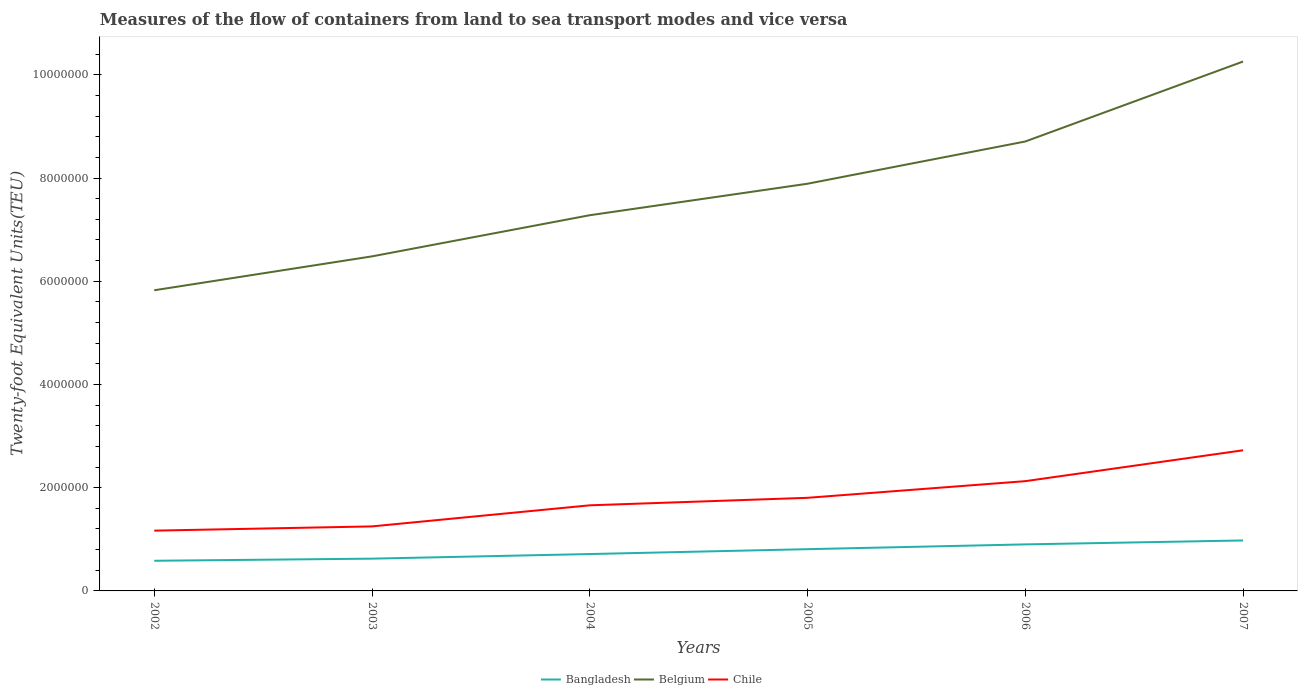Does the line corresponding to Chile intersect with the line corresponding to Belgium?
Provide a succinct answer. No. Across all years, what is the maximum container port traffic in Bangladesh?
Make the answer very short. 5.84e+05. In which year was the container port traffic in Belgium maximum?
Give a very brief answer. 2002. What is the total container port traffic in Belgium in the graph?
Give a very brief answer. -2.98e+06. What is the difference between the highest and the second highest container port traffic in Bangladesh?
Offer a terse response. 3.94e+05. What is the difference between the highest and the lowest container port traffic in Chile?
Your response must be concise. 3. Is the container port traffic in Bangladesh strictly greater than the container port traffic in Chile over the years?
Give a very brief answer. Yes. How many years are there in the graph?
Offer a very short reply. 6. What is the difference between two consecutive major ticks on the Y-axis?
Your response must be concise. 2.00e+06. Are the values on the major ticks of Y-axis written in scientific E-notation?
Your answer should be very brief. No. Where does the legend appear in the graph?
Your answer should be compact. Bottom center. How are the legend labels stacked?
Your response must be concise. Horizontal. What is the title of the graph?
Your answer should be compact. Measures of the flow of containers from land to sea transport modes and vice versa. What is the label or title of the Y-axis?
Provide a succinct answer. Twenty-foot Equivalent Units(TEU). What is the Twenty-foot Equivalent Units(TEU) of Bangladesh in 2002?
Provide a succinct answer. 5.84e+05. What is the Twenty-foot Equivalent Units(TEU) in Belgium in 2002?
Your answer should be very brief. 5.83e+06. What is the Twenty-foot Equivalent Units(TEU) of Chile in 2002?
Make the answer very short. 1.17e+06. What is the Twenty-foot Equivalent Units(TEU) in Bangladesh in 2003?
Your answer should be very brief. 6.25e+05. What is the Twenty-foot Equivalent Units(TEU) of Belgium in 2003?
Offer a terse response. 6.48e+06. What is the Twenty-foot Equivalent Units(TEU) of Chile in 2003?
Your response must be concise. 1.25e+06. What is the Twenty-foot Equivalent Units(TEU) of Bangladesh in 2004?
Provide a succinct answer. 7.14e+05. What is the Twenty-foot Equivalent Units(TEU) of Belgium in 2004?
Provide a short and direct response. 7.28e+06. What is the Twenty-foot Equivalent Units(TEU) of Chile in 2004?
Provide a succinct answer. 1.66e+06. What is the Twenty-foot Equivalent Units(TEU) of Bangladesh in 2005?
Offer a very short reply. 8.09e+05. What is the Twenty-foot Equivalent Units(TEU) of Belgium in 2005?
Your answer should be compact. 7.89e+06. What is the Twenty-foot Equivalent Units(TEU) in Chile in 2005?
Your response must be concise. 1.80e+06. What is the Twenty-foot Equivalent Units(TEU) of Bangladesh in 2006?
Keep it short and to the point. 9.02e+05. What is the Twenty-foot Equivalent Units(TEU) of Belgium in 2006?
Offer a very short reply. 8.71e+06. What is the Twenty-foot Equivalent Units(TEU) in Chile in 2006?
Your answer should be very brief. 2.13e+06. What is the Twenty-foot Equivalent Units(TEU) of Bangladesh in 2007?
Make the answer very short. 9.78e+05. What is the Twenty-foot Equivalent Units(TEU) of Belgium in 2007?
Keep it short and to the point. 1.03e+07. What is the Twenty-foot Equivalent Units(TEU) of Chile in 2007?
Provide a short and direct response. 2.73e+06. Across all years, what is the maximum Twenty-foot Equivalent Units(TEU) in Bangladesh?
Ensure brevity in your answer.  9.78e+05. Across all years, what is the maximum Twenty-foot Equivalent Units(TEU) of Belgium?
Offer a terse response. 1.03e+07. Across all years, what is the maximum Twenty-foot Equivalent Units(TEU) of Chile?
Offer a very short reply. 2.73e+06. Across all years, what is the minimum Twenty-foot Equivalent Units(TEU) in Bangladesh?
Offer a terse response. 5.84e+05. Across all years, what is the minimum Twenty-foot Equivalent Units(TEU) of Belgium?
Your answer should be compact. 5.83e+06. Across all years, what is the minimum Twenty-foot Equivalent Units(TEU) of Chile?
Keep it short and to the point. 1.17e+06. What is the total Twenty-foot Equivalent Units(TEU) of Bangladesh in the graph?
Make the answer very short. 4.61e+06. What is the total Twenty-foot Equivalent Units(TEU) in Belgium in the graph?
Keep it short and to the point. 4.64e+07. What is the total Twenty-foot Equivalent Units(TEU) of Chile in the graph?
Your answer should be very brief. 1.07e+07. What is the difference between the Twenty-foot Equivalent Units(TEU) in Bangladesh in 2002 and that in 2003?
Give a very brief answer. -4.09e+04. What is the difference between the Twenty-foot Equivalent Units(TEU) of Belgium in 2002 and that in 2003?
Your response must be concise. -6.57e+05. What is the difference between the Twenty-foot Equivalent Units(TEU) in Chile in 2002 and that in 2003?
Make the answer very short. -8.22e+04. What is the difference between the Twenty-foot Equivalent Units(TEU) of Bangladesh in 2002 and that in 2004?
Your answer should be compact. -1.30e+05. What is the difference between the Twenty-foot Equivalent Units(TEU) of Belgium in 2002 and that in 2004?
Provide a succinct answer. -1.45e+06. What is the difference between the Twenty-foot Equivalent Units(TEU) in Chile in 2002 and that in 2004?
Make the answer very short. -4.91e+05. What is the difference between the Twenty-foot Equivalent Units(TEU) in Bangladesh in 2002 and that in 2005?
Ensure brevity in your answer.  -2.25e+05. What is the difference between the Twenty-foot Equivalent Units(TEU) of Belgium in 2002 and that in 2005?
Ensure brevity in your answer.  -2.06e+06. What is the difference between the Twenty-foot Equivalent Units(TEU) in Chile in 2002 and that in 2005?
Give a very brief answer. -6.36e+05. What is the difference between the Twenty-foot Equivalent Units(TEU) of Bangladesh in 2002 and that in 2006?
Keep it short and to the point. -3.17e+05. What is the difference between the Twenty-foot Equivalent Units(TEU) of Belgium in 2002 and that in 2006?
Offer a very short reply. -2.88e+06. What is the difference between the Twenty-foot Equivalent Units(TEU) in Chile in 2002 and that in 2006?
Offer a very short reply. -9.59e+05. What is the difference between the Twenty-foot Equivalent Units(TEU) in Bangladesh in 2002 and that in 2007?
Make the answer very short. -3.94e+05. What is the difference between the Twenty-foot Equivalent Units(TEU) in Belgium in 2002 and that in 2007?
Ensure brevity in your answer.  -4.43e+06. What is the difference between the Twenty-foot Equivalent Units(TEU) of Chile in 2002 and that in 2007?
Provide a succinct answer. -1.56e+06. What is the difference between the Twenty-foot Equivalent Units(TEU) of Bangladesh in 2003 and that in 2004?
Keep it short and to the point. -8.93e+04. What is the difference between the Twenty-foot Equivalent Units(TEU) of Belgium in 2003 and that in 2004?
Provide a succinct answer. -7.97e+05. What is the difference between the Twenty-foot Equivalent Units(TEU) of Chile in 2003 and that in 2004?
Offer a terse response. -4.09e+05. What is the difference between the Twenty-foot Equivalent Units(TEU) of Bangladesh in 2003 and that in 2005?
Offer a terse response. -1.84e+05. What is the difference between the Twenty-foot Equivalent Units(TEU) in Belgium in 2003 and that in 2005?
Provide a succinct answer. -1.41e+06. What is the difference between the Twenty-foot Equivalent Units(TEU) in Chile in 2003 and that in 2005?
Provide a short and direct response. -5.54e+05. What is the difference between the Twenty-foot Equivalent Units(TEU) in Bangladesh in 2003 and that in 2006?
Your answer should be very brief. -2.76e+05. What is the difference between the Twenty-foot Equivalent Units(TEU) in Belgium in 2003 and that in 2006?
Offer a terse response. -2.23e+06. What is the difference between the Twenty-foot Equivalent Units(TEU) in Chile in 2003 and that in 2006?
Ensure brevity in your answer.  -8.77e+05. What is the difference between the Twenty-foot Equivalent Units(TEU) of Bangladesh in 2003 and that in 2007?
Your answer should be compact. -3.53e+05. What is the difference between the Twenty-foot Equivalent Units(TEU) in Belgium in 2003 and that in 2007?
Offer a very short reply. -3.78e+06. What is the difference between the Twenty-foot Equivalent Units(TEU) in Chile in 2003 and that in 2007?
Provide a succinct answer. -1.48e+06. What is the difference between the Twenty-foot Equivalent Units(TEU) in Bangladesh in 2004 and that in 2005?
Provide a succinct answer. -9.45e+04. What is the difference between the Twenty-foot Equivalent Units(TEU) in Belgium in 2004 and that in 2005?
Your answer should be very brief. -6.10e+05. What is the difference between the Twenty-foot Equivalent Units(TEU) in Chile in 2004 and that in 2005?
Your answer should be very brief. -1.46e+05. What is the difference between the Twenty-foot Equivalent Units(TEU) of Bangladesh in 2004 and that in 2006?
Ensure brevity in your answer.  -1.87e+05. What is the difference between the Twenty-foot Equivalent Units(TEU) of Belgium in 2004 and that in 2006?
Your answer should be very brief. -1.43e+06. What is the difference between the Twenty-foot Equivalent Units(TEU) of Chile in 2004 and that in 2006?
Ensure brevity in your answer.  -4.68e+05. What is the difference between the Twenty-foot Equivalent Units(TEU) in Bangladesh in 2004 and that in 2007?
Make the answer very short. -2.64e+05. What is the difference between the Twenty-foot Equivalent Units(TEU) in Belgium in 2004 and that in 2007?
Your answer should be compact. -2.98e+06. What is the difference between the Twenty-foot Equivalent Units(TEU) in Chile in 2004 and that in 2007?
Make the answer very short. -1.07e+06. What is the difference between the Twenty-foot Equivalent Units(TEU) in Bangladesh in 2005 and that in 2006?
Your answer should be compact. -9.26e+04. What is the difference between the Twenty-foot Equivalent Units(TEU) in Belgium in 2005 and that in 2006?
Provide a short and direct response. -8.18e+05. What is the difference between the Twenty-foot Equivalent Units(TEU) of Chile in 2005 and that in 2006?
Ensure brevity in your answer.  -3.23e+05. What is the difference between the Twenty-foot Equivalent Units(TEU) in Bangladesh in 2005 and that in 2007?
Keep it short and to the point. -1.69e+05. What is the difference between the Twenty-foot Equivalent Units(TEU) in Belgium in 2005 and that in 2007?
Your response must be concise. -2.37e+06. What is the difference between the Twenty-foot Equivalent Units(TEU) of Chile in 2005 and that in 2007?
Offer a terse response. -9.21e+05. What is the difference between the Twenty-foot Equivalent Units(TEU) of Bangladesh in 2006 and that in 2007?
Give a very brief answer. -7.65e+04. What is the difference between the Twenty-foot Equivalent Units(TEU) in Belgium in 2006 and that in 2007?
Your answer should be very brief. -1.55e+06. What is the difference between the Twenty-foot Equivalent Units(TEU) in Chile in 2006 and that in 2007?
Keep it short and to the point. -5.98e+05. What is the difference between the Twenty-foot Equivalent Units(TEU) of Bangladesh in 2002 and the Twenty-foot Equivalent Units(TEU) of Belgium in 2003?
Make the answer very short. -5.90e+06. What is the difference between the Twenty-foot Equivalent Units(TEU) of Bangladesh in 2002 and the Twenty-foot Equivalent Units(TEU) of Chile in 2003?
Make the answer very short. -6.66e+05. What is the difference between the Twenty-foot Equivalent Units(TEU) in Belgium in 2002 and the Twenty-foot Equivalent Units(TEU) in Chile in 2003?
Ensure brevity in your answer.  4.58e+06. What is the difference between the Twenty-foot Equivalent Units(TEU) of Bangladesh in 2002 and the Twenty-foot Equivalent Units(TEU) of Belgium in 2004?
Provide a succinct answer. -6.70e+06. What is the difference between the Twenty-foot Equivalent Units(TEU) in Bangladesh in 2002 and the Twenty-foot Equivalent Units(TEU) in Chile in 2004?
Offer a terse response. -1.07e+06. What is the difference between the Twenty-foot Equivalent Units(TEU) in Belgium in 2002 and the Twenty-foot Equivalent Units(TEU) in Chile in 2004?
Your response must be concise. 4.17e+06. What is the difference between the Twenty-foot Equivalent Units(TEU) of Bangladesh in 2002 and the Twenty-foot Equivalent Units(TEU) of Belgium in 2005?
Your response must be concise. -7.31e+06. What is the difference between the Twenty-foot Equivalent Units(TEU) of Bangladesh in 2002 and the Twenty-foot Equivalent Units(TEU) of Chile in 2005?
Your answer should be very brief. -1.22e+06. What is the difference between the Twenty-foot Equivalent Units(TEU) in Belgium in 2002 and the Twenty-foot Equivalent Units(TEU) in Chile in 2005?
Provide a succinct answer. 4.02e+06. What is the difference between the Twenty-foot Equivalent Units(TEU) of Bangladesh in 2002 and the Twenty-foot Equivalent Units(TEU) of Belgium in 2006?
Give a very brief answer. -8.12e+06. What is the difference between the Twenty-foot Equivalent Units(TEU) of Bangladesh in 2002 and the Twenty-foot Equivalent Units(TEU) of Chile in 2006?
Make the answer very short. -1.54e+06. What is the difference between the Twenty-foot Equivalent Units(TEU) in Belgium in 2002 and the Twenty-foot Equivalent Units(TEU) in Chile in 2006?
Your response must be concise. 3.70e+06. What is the difference between the Twenty-foot Equivalent Units(TEU) in Bangladesh in 2002 and the Twenty-foot Equivalent Units(TEU) in Belgium in 2007?
Your answer should be very brief. -9.67e+06. What is the difference between the Twenty-foot Equivalent Units(TEU) of Bangladesh in 2002 and the Twenty-foot Equivalent Units(TEU) of Chile in 2007?
Your answer should be compact. -2.14e+06. What is the difference between the Twenty-foot Equivalent Units(TEU) of Belgium in 2002 and the Twenty-foot Equivalent Units(TEU) of Chile in 2007?
Give a very brief answer. 3.10e+06. What is the difference between the Twenty-foot Equivalent Units(TEU) of Bangladesh in 2003 and the Twenty-foot Equivalent Units(TEU) of Belgium in 2004?
Ensure brevity in your answer.  -6.65e+06. What is the difference between the Twenty-foot Equivalent Units(TEU) in Bangladesh in 2003 and the Twenty-foot Equivalent Units(TEU) in Chile in 2004?
Your answer should be very brief. -1.03e+06. What is the difference between the Twenty-foot Equivalent Units(TEU) in Belgium in 2003 and the Twenty-foot Equivalent Units(TEU) in Chile in 2004?
Provide a succinct answer. 4.82e+06. What is the difference between the Twenty-foot Equivalent Units(TEU) in Bangladesh in 2003 and the Twenty-foot Equivalent Units(TEU) in Belgium in 2005?
Your response must be concise. -7.26e+06. What is the difference between the Twenty-foot Equivalent Units(TEU) of Bangladesh in 2003 and the Twenty-foot Equivalent Units(TEU) of Chile in 2005?
Your answer should be compact. -1.18e+06. What is the difference between the Twenty-foot Equivalent Units(TEU) of Belgium in 2003 and the Twenty-foot Equivalent Units(TEU) of Chile in 2005?
Offer a terse response. 4.68e+06. What is the difference between the Twenty-foot Equivalent Units(TEU) of Bangladesh in 2003 and the Twenty-foot Equivalent Units(TEU) of Belgium in 2006?
Make the answer very short. -8.08e+06. What is the difference between the Twenty-foot Equivalent Units(TEU) of Bangladesh in 2003 and the Twenty-foot Equivalent Units(TEU) of Chile in 2006?
Your answer should be very brief. -1.50e+06. What is the difference between the Twenty-foot Equivalent Units(TEU) of Belgium in 2003 and the Twenty-foot Equivalent Units(TEU) of Chile in 2006?
Your answer should be very brief. 4.36e+06. What is the difference between the Twenty-foot Equivalent Units(TEU) in Bangladesh in 2003 and the Twenty-foot Equivalent Units(TEU) in Belgium in 2007?
Give a very brief answer. -9.63e+06. What is the difference between the Twenty-foot Equivalent Units(TEU) of Bangladesh in 2003 and the Twenty-foot Equivalent Units(TEU) of Chile in 2007?
Ensure brevity in your answer.  -2.10e+06. What is the difference between the Twenty-foot Equivalent Units(TEU) in Belgium in 2003 and the Twenty-foot Equivalent Units(TEU) in Chile in 2007?
Offer a very short reply. 3.76e+06. What is the difference between the Twenty-foot Equivalent Units(TEU) of Bangladesh in 2004 and the Twenty-foot Equivalent Units(TEU) of Belgium in 2005?
Your response must be concise. -7.18e+06. What is the difference between the Twenty-foot Equivalent Units(TEU) in Bangladesh in 2004 and the Twenty-foot Equivalent Units(TEU) in Chile in 2005?
Offer a terse response. -1.09e+06. What is the difference between the Twenty-foot Equivalent Units(TEU) of Belgium in 2004 and the Twenty-foot Equivalent Units(TEU) of Chile in 2005?
Give a very brief answer. 5.48e+06. What is the difference between the Twenty-foot Equivalent Units(TEU) in Bangladesh in 2004 and the Twenty-foot Equivalent Units(TEU) in Belgium in 2006?
Provide a short and direct response. -7.99e+06. What is the difference between the Twenty-foot Equivalent Units(TEU) of Bangladesh in 2004 and the Twenty-foot Equivalent Units(TEU) of Chile in 2006?
Ensure brevity in your answer.  -1.41e+06. What is the difference between the Twenty-foot Equivalent Units(TEU) in Belgium in 2004 and the Twenty-foot Equivalent Units(TEU) in Chile in 2006?
Offer a very short reply. 5.15e+06. What is the difference between the Twenty-foot Equivalent Units(TEU) of Bangladesh in 2004 and the Twenty-foot Equivalent Units(TEU) of Belgium in 2007?
Offer a very short reply. -9.54e+06. What is the difference between the Twenty-foot Equivalent Units(TEU) in Bangladesh in 2004 and the Twenty-foot Equivalent Units(TEU) in Chile in 2007?
Provide a succinct answer. -2.01e+06. What is the difference between the Twenty-foot Equivalent Units(TEU) of Belgium in 2004 and the Twenty-foot Equivalent Units(TEU) of Chile in 2007?
Give a very brief answer. 4.55e+06. What is the difference between the Twenty-foot Equivalent Units(TEU) in Bangladesh in 2005 and the Twenty-foot Equivalent Units(TEU) in Belgium in 2006?
Your response must be concise. -7.90e+06. What is the difference between the Twenty-foot Equivalent Units(TEU) of Bangladesh in 2005 and the Twenty-foot Equivalent Units(TEU) of Chile in 2006?
Provide a succinct answer. -1.32e+06. What is the difference between the Twenty-foot Equivalent Units(TEU) of Belgium in 2005 and the Twenty-foot Equivalent Units(TEU) of Chile in 2006?
Offer a terse response. 5.76e+06. What is the difference between the Twenty-foot Equivalent Units(TEU) of Bangladesh in 2005 and the Twenty-foot Equivalent Units(TEU) of Belgium in 2007?
Offer a very short reply. -9.45e+06. What is the difference between the Twenty-foot Equivalent Units(TEU) of Bangladesh in 2005 and the Twenty-foot Equivalent Units(TEU) of Chile in 2007?
Ensure brevity in your answer.  -1.92e+06. What is the difference between the Twenty-foot Equivalent Units(TEU) of Belgium in 2005 and the Twenty-foot Equivalent Units(TEU) of Chile in 2007?
Provide a succinct answer. 5.16e+06. What is the difference between the Twenty-foot Equivalent Units(TEU) in Bangladesh in 2006 and the Twenty-foot Equivalent Units(TEU) in Belgium in 2007?
Give a very brief answer. -9.36e+06. What is the difference between the Twenty-foot Equivalent Units(TEU) in Bangladesh in 2006 and the Twenty-foot Equivalent Units(TEU) in Chile in 2007?
Your response must be concise. -1.82e+06. What is the difference between the Twenty-foot Equivalent Units(TEU) of Belgium in 2006 and the Twenty-foot Equivalent Units(TEU) of Chile in 2007?
Your answer should be compact. 5.98e+06. What is the average Twenty-foot Equivalent Units(TEU) of Bangladesh per year?
Keep it short and to the point. 7.69e+05. What is the average Twenty-foot Equivalent Units(TEU) of Belgium per year?
Your response must be concise. 7.74e+06. What is the average Twenty-foot Equivalent Units(TEU) in Chile per year?
Your response must be concise. 1.79e+06. In the year 2002, what is the difference between the Twenty-foot Equivalent Units(TEU) in Bangladesh and Twenty-foot Equivalent Units(TEU) in Belgium?
Offer a terse response. -5.24e+06. In the year 2002, what is the difference between the Twenty-foot Equivalent Units(TEU) in Bangladesh and Twenty-foot Equivalent Units(TEU) in Chile?
Your answer should be compact. -5.84e+05. In the year 2002, what is the difference between the Twenty-foot Equivalent Units(TEU) in Belgium and Twenty-foot Equivalent Units(TEU) in Chile?
Provide a short and direct response. 4.66e+06. In the year 2003, what is the difference between the Twenty-foot Equivalent Units(TEU) of Bangladesh and Twenty-foot Equivalent Units(TEU) of Belgium?
Make the answer very short. -5.86e+06. In the year 2003, what is the difference between the Twenty-foot Equivalent Units(TEU) in Bangladesh and Twenty-foot Equivalent Units(TEU) in Chile?
Your answer should be compact. -6.25e+05. In the year 2003, what is the difference between the Twenty-foot Equivalent Units(TEU) of Belgium and Twenty-foot Equivalent Units(TEU) of Chile?
Make the answer very short. 5.23e+06. In the year 2004, what is the difference between the Twenty-foot Equivalent Units(TEU) in Bangladesh and Twenty-foot Equivalent Units(TEU) in Belgium?
Make the answer very short. -6.57e+06. In the year 2004, what is the difference between the Twenty-foot Equivalent Units(TEU) in Bangladesh and Twenty-foot Equivalent Units(TEU) in Chile?
Your answer should be very brief. -9.44e+05. In the year 2004, what is the difference between the Twenty-foot Equivalent Units(TEU) in Belgium and Twenty-foot Equivalent Units(TEU) in Chile?
Ensure brevity in your answer.  5.62e+06. In the year 2005, what is the difference between the Twenty-foot Equivalent Units(TEU) in Bangladesh and Twenty-foot Equivalent Units(TEU) in Belgium?
Your response must be concise. -7.08e+06. In the year 2005, what is the difference between the Twenty-foot Equivalent Units(TEU) of Bangladesh and Twenty-foot Equivalent Units(TEU) of Chile?
Offer a very short reply. -9.95e+05. In the year 2005, what is the difference between the Twenty-foot Equivalent Units(TEU) in Belgium and Twenty-foot Equivalent Units(TEU) in Chile?
Give a very brief answer. 6.09e+06. In the year 2006, what is the difference between the Twenty-foot Equivalent Units(TEU) of Bangladesh and Twenty-foot Equivalent Units(TEU) of Belgium?
Provide a short and direct response. -7.81e+06. In the year 2006, what is the difference between the Twenty-foot Equivalent Units(TEU) in Bangladesh and Twenty-foot Equivalent Units(TEU) in Chile?
Give a very brief answer. -1.23e+06. In the year 2006, what is the difference between the Twenty-foot Equivalent Units(TEU) of Belgium and Twenty-foot Equivalent Units(TEU) of Chile?
Give a very brief answer. 6.58e+06. In the year 2007, what is the difference between the Twenty-foot Equivalent Units(TEU) in Bangladesh and Twenty-foot Equivalent Units(TEU) in Belgium?
Keep it short and to the point. -9.28e+06. In the year 2007, what is the difference between the Twenty-foot Equivalent Units(TEU) of Bangladesh and Twenty-foot Equivalent Units(TEU) of Chile?
Keep it short and to the point. -1.75e+06. In the year 2007, what is the difference between the Twenty-foot Equivalent Units(TEU) in Belgium and Twenty-foot Equivalent Units(TEU) in Chile?
Provide a short and direct response. 7.53e+06. What is the ratio of the Twenty-foot Equivalent Units(TEU) of Bangladesh in 2002 to that in 2003?
Ensure brevity in your answer.  0.93. What is the ratio of the Twenty-foot Equivalent Units(TEU) of Belgium in 2002 to that in 2003?
Keep it short and to the point. 0.9. What is the ratio of the Twenty-foot Equivalent Units(TEU) of Chile in 2002 to that in 2003?
Offer a very short reply. 0.93. What is the ratio of the Twenty-foot Equivalent Units(TEU) of Bangladesh in 2002 to that in 2004?
Provide a short and direct response. 0.82. What is the ratio of the Twenty-foot Equivalent Units(TEU) in Belgium in 2002 to that in 2004?
Keep it short and to the point. 0.8. What is the ratio of the Twenty-foot Equivalent Units(TEU) in Chile in 2002 to that in 2004?
Give a very brief answer. 0.7. What is the ratio of the Twenty-foot Equivalent Units(TEU) of Bangladesh in 2002 to that in 2005?
Your response must be concise. 0.72. What is the ratio of the Twenty-foot Equivalent Units(TEU) in Belgium in 2002 to that in 2005?
Offer a very short reply. 0.74. What is the ratio of the Twenty-foot Equivalent Units(TEU) in Chile in 2002 to that in 2005?
Make the answer very short. 0.65. What is the ratio of the Twenty-foot Equivalent Units(TEU) of Bangladesh in 2002 to that in 2006?
Your response must be concise. 0.65. What is the ratio of the Twenty-foot Equivalent Units(TEU) of Belgium in 2002 to that in 2006?
Provide a succinct answer. 0.67. What is the ratio of the Twenty-foot Equivalent Units(TEU) in Chile in 2002 to that in 2006?
Provide a short and direct response. 0.55. What is the ratio of the Twenty-foot Equivalent Units(TEU) in Bangladesh in 2002 to that in 2007?
Ensure brevity in your answer.  0.6. What is the ratio of the Twenty-foot Equivalent Units(TEU) in Belgium in 2002 to that in 2007?
Ensure brevity in your answer.  0.57. What is the ratio of the Twenty-foot Equivalent Units(TEU) of Chile in 2002 to that in 2007?
Provide a succinct answer. 0.43. What is the ratio of the Twenty-foot Equivalent Units(TEU) in Bangladesh in 2003 to that in 2004?
Offer a terse response. 0.88. What is the ratio of the Twenty-foot Equivalent Units(TEU) of Belgium in 2003 to that in 2004?
Keep it short and to the point. 0.89. What is the ratio of the Twenty-foot Equivalent Units(TEU) of Chile in 2003 to that in 2004?
Your answer should be compact. 0.75. What is the ratio of the Twenty-foot Equivalent Units(TEU) of Bangladesh in 2003 to that in 2005?
Provide a short and direct response. 0.77. What is the ratio of the Twenty-foot Equivalent Units(TEU) of Belgium in 2003 to that in 2005?
Provide a succinct answer. 0.82. What is the ratio of the Twenty-foot Equivalent Units(TEU) of Chile in 2003 to that in 2005?
Give a very brief answer. 0.69. What is the ratio of the Twenty-foot Equivalent Units(TEU) in Bangladesh in 2003 to that in 2006?
Offer a terse response. 0.69. What is the ratio of the Twenty-foot Equivalent Units(TEU) in Belgium in 2003 to that in 2006?
Offer a terse response. 0.74. What is the ratio of the Twenty-foot Equivalent Units(TEU) of Chile in 2003 to that in 2006?
Give a very brief answer. 0.59. What is the ratio of the Twenty-foot Equivalent Units(TEU) in Bangladesh in 2003 to that in 2007?
Your response must be concise. 0.64. What is the ratio of the Twenty-foot Equivalent Units(TEU) of Belgium in 2003 to that in 2007?
Give a very brief answer. 0.63. What is the ratio of the Twenty-foot Equivalent Units(TEU) of Chile in 2003 to that in 2007?
Provide a short and direct response. 0.46. What is the ratio of the Twenty-foot Equivalent Units(TEU) in Bangladesh in 2004 to that in 2005?
Your answer should be compact. 0.88. What is the ratio of the Twenty-foot Equivalent Units(TEU) of Belgium in 2004 to that in 2005?
Offer a very short reply. 0.92. What is the ratio of the Twenty-foot Equivalent Units(TEU) in Chile in 2004 to that in 2005?
Offer a very short reply. 0.92. What is the ratio of the Twenty-foot Equivalent Units(TEU) in Bangladesh in 2004 to that in 2006?
Your answer should be compact. 0.79. What is the ratio of the Twenty-foot Equivalent Units(TEU) of Belgium in 2004 to that in 2006?
Keep it short and to the point. 0.84. What is the ratio of the Twenty-foot Equivalent Units(TEU) in Chile in 2004 to that in 2006?
Ensure brevity in your answer.  0.78. What is the ratio of the Twenty-foot Equivalent Units(TEU) in Bangladesh in 2004 to that in 2007?
Provide a short and direct response. 0.73. What is the ratio of the Twenty-foot Equivalent Units(TEU) of Belgium in 2004 to that in 2007?
Give a very brief answer. 0.71. What is the ratio of the Twenty-foot Equivalent Units(TEU) in Chile in 2004 to that in 2007?
Your answer should be compact. 0.61. What is the ratio of the Twenty-foot Equivalent Units(TEU) of Bangladesh in 2005 to that in 2006?
Ensure brevity in your answer.  0.9. What is the ratio of the Twenty-foot Equivalent Units(TEU) of Belgium in 2005 to that in 2006?
Your answer should be compact. 0.91. What is the ratio of the Twenty-foot Equivalent Units(TEU) in Chile in 2005 to that in 2006?
Your answer should be very brief. 0.85. What is the ratio of the Twenty-foot Equivalent Units(TEU) in Bangladesh in 2005 to that in 2007?
Offer a very short reply. 0.83. What is the ratio of the Twenty-foot Equivalent Units(TEU) in Belgium in 2005 to that in 2007?
Provide a short and direct response. 0.77. What is the ratio of the Twenty-foot Equivalent Units(TEU) in Chile in 2005 to that in 2007?
Provide a short and direct response. 0.66. What is the ratio of the Twenty-foot Equivalent Units(TEU) of Bangladesh in 2006 to that in 2007?
Give a very brief answer. 0.92. What is the ratio of the Twenty-foot Equivalent Units(TEU) of Belgium in 2006 to that in 2007?
Provide a succinct answer. 0.85. What is the ratio of the Twenty-foot Equivalent Units(TEU) in Chile in 2006 to that in 2007?
Your response must be concise. 0.78. What is the difference between the highest and the second highest Twenty-foot Equivalent Units(TEU) in Bangladesh?
Your answer should be very brief. 7.65e+04. What is the difference between the highest and the second highest Twenty-foot Equivalent Units(TEU) of Belgium?
Offer a very short reply. 1.55e+06. What is the difference between the highest and the second highest Twenty-foot Equivalent Units(TEU) in Chile?
Offer a terse response. 5.98e+05. What is the difference between the highest and the lowest Twenty-foot Equivalent Units(TEU) of Bangladesh?
Ensure brevity in your answer.  3.94e+05. What is the difference between the highest and the lowest Twenty-foot Equivalent Units(TEU) in Belgium?
Keep it short and to the point. 4.43e+06. What is the difference between the highest and the lowest Twenty-foot Equivalent Units(TEU) of Chile?
Your answer should be compact. 1.56e+06. 